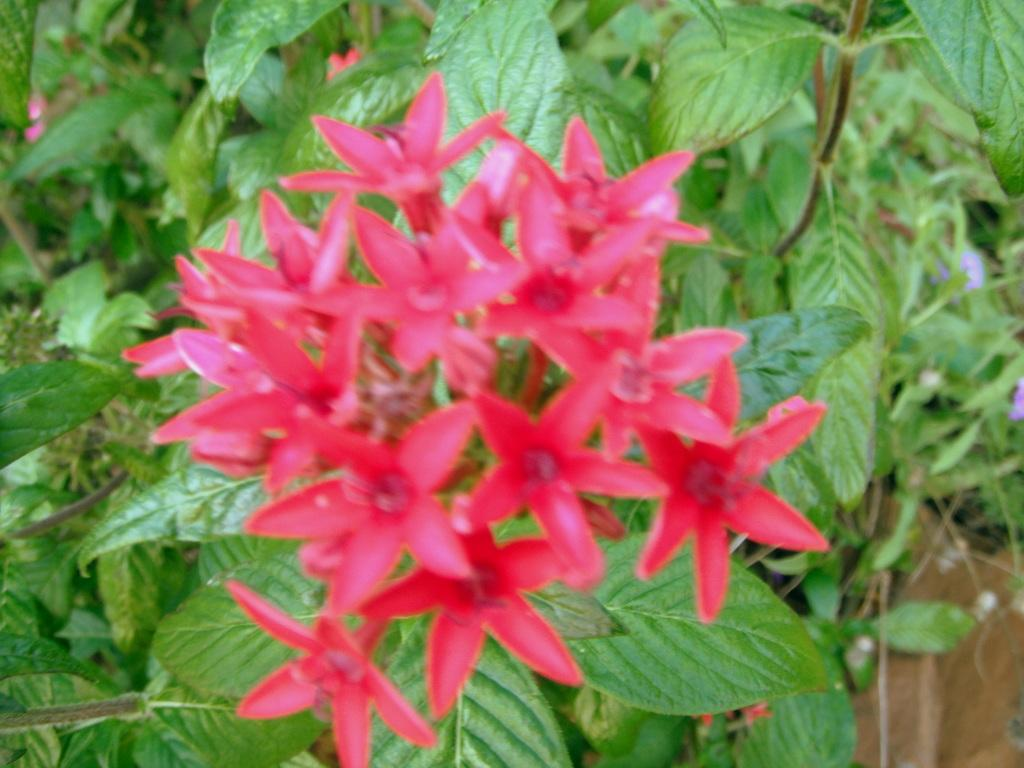What type of vegetation can be seen in the background of the image? There are flowers and trees in the background of the image. Can you describe the natural setting visible in the image? The natural setting includes flowers and trees in the background. Can you see a horse swimming in the ocean in the image? There is no horse or ocean present in the image. What type of bird can be seen perched on the tree in the image? There is no bird present in the image, so it is not possible to determine what type of bird might be perched on the tree. 